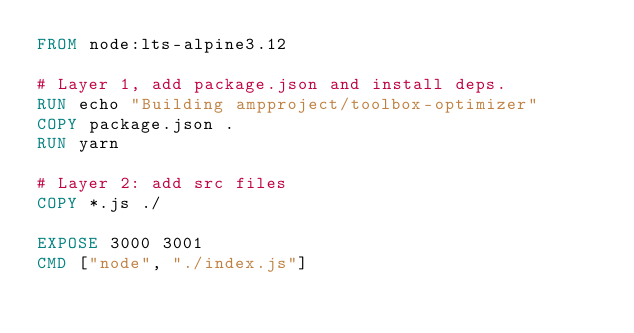Convert code to text. <code><loc_0><loc_0><loc_500><loc_500><_Dockerfile_>FROM node:lts-alpine3.12

# Layer 1, add package.json and install deps.
RUN echo "Building ampproject/toolbox-optimizer"
COPY package.json .
RUN yarn

# Layer 2: add src files
COPY *.js ./

EXPOSE 3000 3001
CMD ["node", "./index.js"]
</code> 